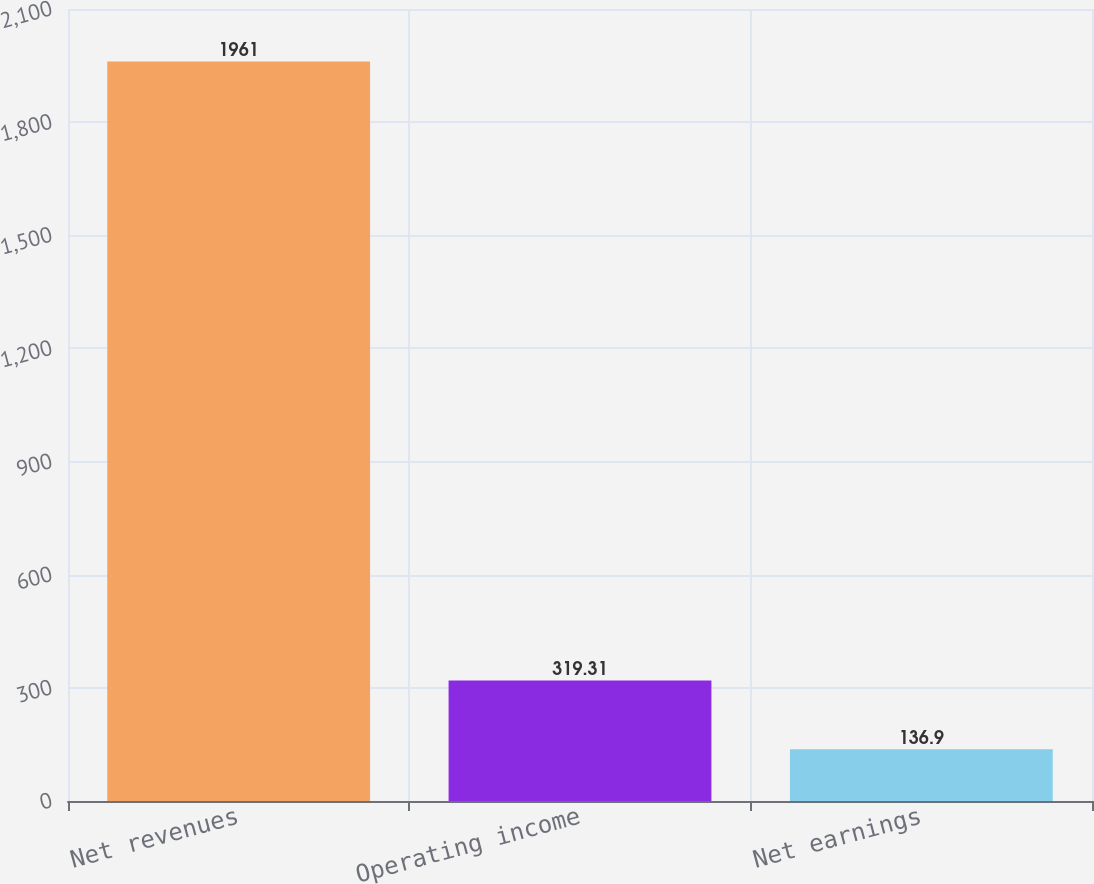Convert chart. <chart><loc_0><loc_0><loc_500><loc_500><bar_chart><fcel>Net revenues<fcel>Operating income<fcel>Net earnings<nl><fcel>1961<fcel>319.31<fcel>136.9<nl></chart> 